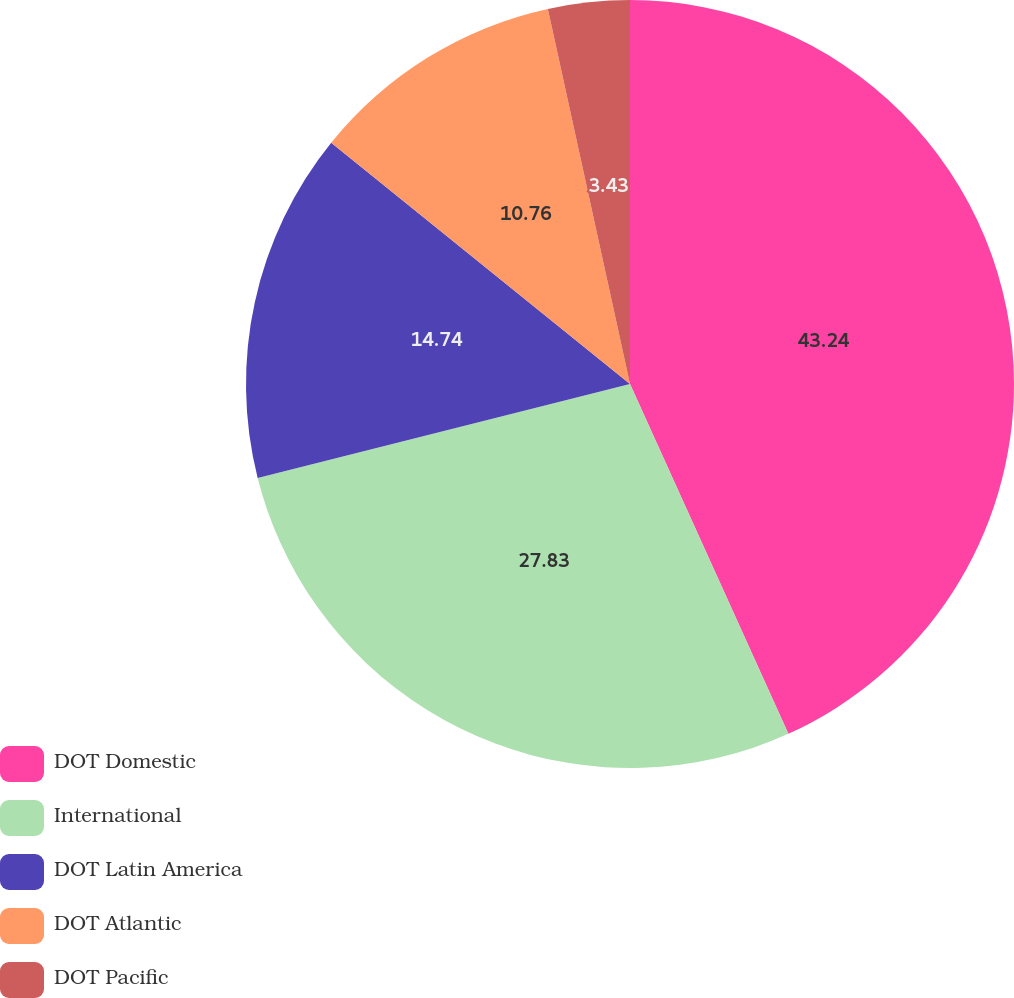Convert chart. <chart><loc_0><loc_0><loc_500><loc_500><pie_chart><fcel>DOT Domestic<fcel>International<fcel>DOT Latin America<fcel>DOT Atlantic<fcel>DOT Pacific<nl><fcel>43.23%<fcel>27.83%<fcel>14.74%<fcel>10.76%<fcel>3.43%<nl></chart> 